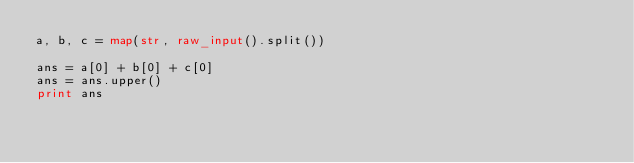<code> <loc_0><loc_0><loc_500><loc_500><_Python_>a, b, c = map(str, raw_input().split())
 
ans = a[0] + b[0] + c[0]
ans = ans.upper()
print ans</code> 